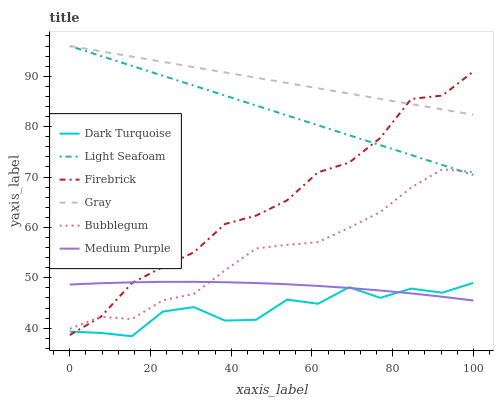Does Firebrick have the minimum area under the curve?
Answer yes or no. No. Does Firebrick have the maximum area under the curve?
Answer yes or no. No. Is Firebrick the smoothest?
Answer yes or no. No. Is Firebrick the roughest?
Answer yes or no. No. Does Firebrick have the lowest value?
Answer yes or no. No. Does Firebrick have the highest value?
Answer yes or no. No. Is Dark Turquoise less than Light Seafoam?
Answer yes or no. Yes. Is Gray greater than Medium Purple?
Answer yes or no. Yes. Does Dark Turquoise intersect Light Seafoam?
Answer yes or no. No. 